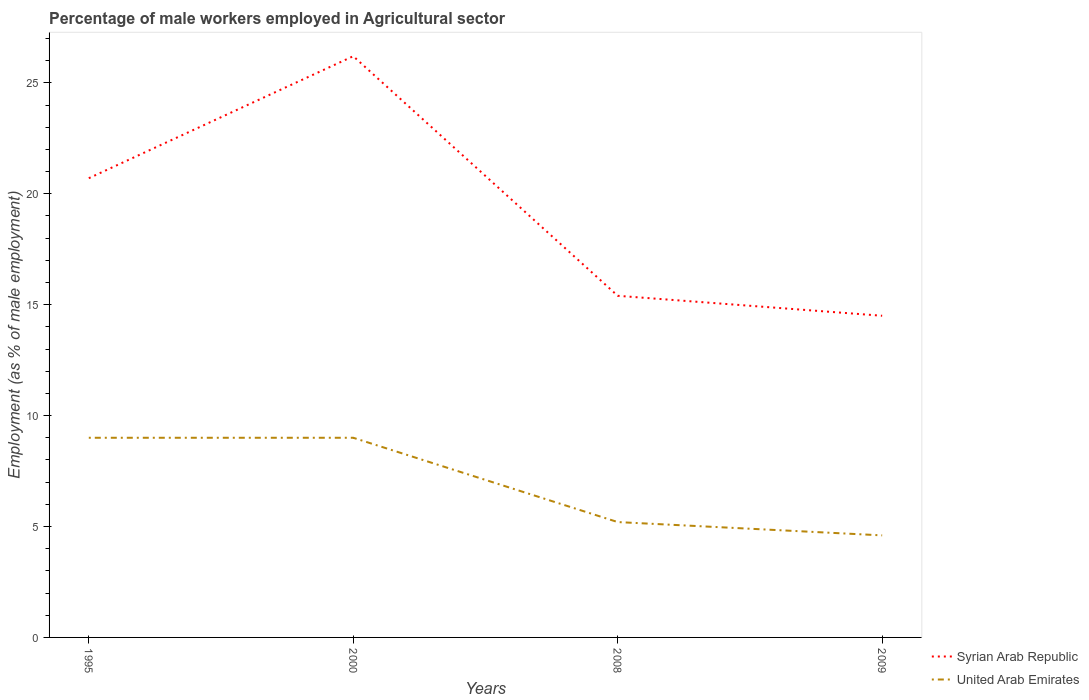How many different coloured lines are there?
Provide a succinct answer. 2. Does the line corresponding to United Arab Emirates intersect with the line corresponding to Syrian Arab Republic?
Give a very brief answer. No. Across all years, what is the maximum percentage of male workers employed in Agricultural sector in United Arab Emirates?
Give a very brief answer. 4.6. What is the total percentage of male workers employed in Agricultural sector in United Arab Emirates in the graph?
Offer a very short reply. 4.4. What is the difference between the highest and the second highest percentage of male workers employed in Agricultural sector in United Arab Emirates?
Offer a very short reply. 4.4. Is the percentage of male workers employed in Agricultural sector in Syrian Arab Republic strictly greater than the percentage of male workers employed in Agricultural sector in United Arab Emirates over the years?
Provide a short and direct response. No. How many years are there in the graph?
Give a very brief answer. 4. Does the graph contain any zero values?
Your response must be concise. No. How many legend labels are there?
Ensure brevity in your answer.  2. What is the title of the graph?
Your answer should be very brief. Percentage of male workers employed in Agricultural sector. What is the label or title of the X-axis?
Keep it short and to the point. Years. What is the label or title of the Y-axis?
Provide a short and direct response. Employment (as % of male employment). What is the Employment (as % of male employment) of Syrian Arab Republic in 1995?
Provide a short and direct response. 20.7. What is the Employment (as % of male employment) in United Arab Emirates in 1995?
Make the answer very short. 9. What is the Employment (as % of male employment) in Syrian Arab Republic in 2000?
Offer a terse response. 26.2. What is the Employment (as % of male employment) of United Arab Emirates in 2000?
Ensure brevity in your answer.  9. What is the Employment (as % of male employment) of Syrian Arab Republic in 2008?
Offer a terse response. 15.4. What is the Employment (as % of male employment) in United Arab Emirates in 2008?
Keep it short and to the point. 5.2. What is the Employment (as % of male employment) in United Arab Emirates in 2009?
Your answer should be compact. 4.6. Across all years, what is the maximum Employment (as % of male employment) of Syrian Arab Republic?
Ensure brevity in your answer.  26.2. Across all years, what is the minimum Employment (as % of male employment) in United Arab Emirates?
Your answer should be very brief. 4.6. What is the total Employment (as % of male employment) in Syrian Arab Republic in the graph?
Ensure brevity in your answer.  76.8. What is the total Employment (as % of male employment) in United Arab Emirates in the graph?
Give a very brief answer. 27.8. What is the difference between the Employment (as % of male employment) of Syrian Arab Republic in 1995 and that in 2000?
Your answer should be very brief. -5.5. What is the difference between the Employment (as % of male employment) of United Arab Emirates in 1995 and that in 2000?
Your answer should be very brief. 0. What is the difference between the Employment (as % of male employment) in Syrian Arab Republic in 1995 and that in 2008?
Give a very brief answer. 5.3. What is the difference between the Employment (as % of male employment) of United Arab Emirates in 1995 and that in 2009?
Give a very brief answer. 4.4. What is the difference between the Employment (as % of male employment) of Syrian Arab Republic in 2000 and that in 2008?
Your response must be concise. 10.8. What is the difference between the Employment (as % of male employment) of United Arab Emirates in 2000 and that in 2008?
Your answer should be compact. 3.8. What is the difference between the Employment (as % of male employment) of Syrian Arab Republic in 2000 and that in 2009?
Offer a terse response. 11.7. What is the difference between the Employment (as % of male employment) in Syrian Arab Republic in 1995 and the Employment (as % of male employment) in United Arab Emirates in 2000?
Ensure brevity in your answer.  11.7. What is the difference between the Employment (as % of male employment) of Syrian Arab Republic in 1995 and the Employment (as % of male employment) of United Arab Emirates in 2008?
Provide a succinct answer. 15.5. What is the difference between the Employment (as % of male employment) in Syrian Arab Republic in 1995 and the Employment (as % of male employment) in United Arab Emirates in 2009?
Ensure brevity in your answer.  16.1. What is the difference between the Employment (as % of male employment) in Syrian Arab Republic in 2000 and the Employment (as % of male employment) in United Arab Emirates in 2009?
Keep it short and to the point. 21.6. What is the difference between the Employment (as % of male employment) in Syrian Arab Republic in 2008 and the Employment (as % of male employment) in United Arab Emirates in 2009?
Your answer should be very brief. 10.8. What is the average Employment (as % of male employment) in United Arab Emirates per year?
Make the answer very short. 6.95. In the year 1995, what is the difference between the Employment (as % of male employment) of Syrian Arab Republic and Employment (as % of male employment) of United Arab Emirates?
Make the answer very short. 11.7. In the year 2000, what is the difference between the Employment (as % of male employment) in Syrian Arab Republic and Employment (as % of male employment) in United Arab Emirates?
Your answer should be very brief. 17.2. In the year 2008, what is the difference between the Employment (as % of male employment) of Syrian Arab Republic and Employment (as % of male employment) of United Arab Emirates?
Make the answer very short. 10.2. What is the ratio of the Employment (as % of male employment) of Syrian Arab Republic in 1995 to that in 2000?
Provide a short and direct response. 0.79. What is the ratio of the Employment (as % of male employment) in United Arab Emirates in 1995 to that in 2000?
Your answer should be very brief. 1. What is the ratio of the Employment (as % of male employment) in Syrian Arab Republic in 1995 to that in 2008?
Your response must be concise. 1.34. What is the ratio of the Employment (as % of male employment) of United Arab Emirates in 1995 to that in 2008?
Ensure brevity in your answer.  1.73. What is the ratio of the Employment (as % of male employment) in Syrian Arab Republic in 1995 to that in 2009?
Give a very brief answer. 1.43. What is the ratio of the Employment (as % of male employment) of United Arab Emirates in 1995 to that in 2009?
Your response must be concise. 1.96. What is the ratio of the Employment (as % of male employment) in Syrian Arab Republic in 2000 to that in 2008?
Your answer should be very brief. 1.7. What is the ratio of the Employment (as % of male employment) in United Arab Emirates in 2000 to that in 2008?
Your answer should be very brief. 1.73. What is the ratio of the Employment (as % of male employment) in Syrian Arab Republic in 2000 to that in 2009?
Keep it short and to the point. 1.81. What is the ratio of the Employment (as % of male employment) in United Arab Emirates in 2000 to that in 2009?
Your answer should be compact. 1.96. What is the ratio of the Employment (as % of male employment) in Syrian Arab Republic in 2008 to that in 2009?
Ensure brevity in your answer.  1.06. What is the ratio of the Employment (as % of male employment) of United Arab Emirates in 2008 to that in 2009?
Offer a very short reply. 1.13. What is the difference between the highest and the second highest Employment (as % of male employment) of Syrian Arab Republic?
Your answer should be very brief. 5.5. What is the difference between the highest and the second highest Employment (as % of male employment) of United Arab Emirates?
Your answer should be very brief. 0. What is the difference between the highest and the lowest Employment (as % of male employment) of Syrian Arab Republic?
Your response must be concise. 11.7. What is the difference between the highest and the lowest Employment (as % of male employment) in United Arab Emirates?
Give a very brief answer. 4.4. 